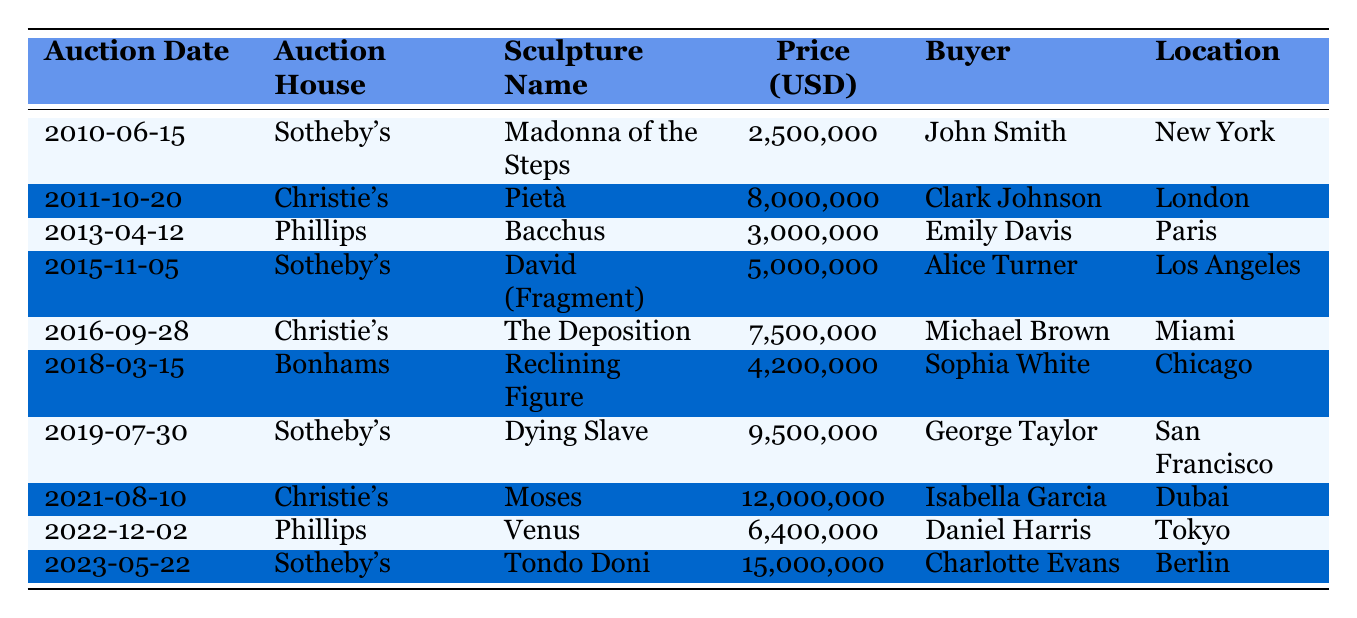What is the highest auction price for a Michelangelo sculpture? The highest price in the table is found in the last entry for "Tondo Doni" at $15,000,000.
Answer: $15,000,000 Who bought the "Pietà"? The buyer for the "Pietà," auctioned on 2011-10-20 at Christie's, is Clark Johnson.
Answer: Clark Johnson How many times was Sotheby's the auction house for Michelangelo's sculptures in this period? By counting the entries in the table, Sotheby's appears 4 times: in 2010, 2015, 2019, and 2023.
Answer: 4 times Which sculpture had the lowest price and who was the buyer? The lowest priced sculpture is "Madonna of the Steps" at $2,500,000, purchased by John Smith.
Answer: "Madonna of the Steps," John Smith What was the average auction price of all the Michelangelo sculptures listed? The total sum of all prices is $66,400,000, and there are 10 sculptures, so the average price is $66,400,000 / 10 = $6,640,000.
Answer: $6,640,000 Did any sculpture sell for more than $10 million? Yes, there are two sculptures that sold for more than $10 million: "Moses" and "Tondo Doni."
Answer: Yes What sculpture was auctioned first, and at what price? The first auction listed is "Madonna of the Steps" on 2010-06-15, and it was sold for $2,500,000.
Answer: "Madonna of the Steps," $2,500,000 In which city was the "Dying Slave" auctioned? The "Dying Slave" sculpture was auctioned on 2019-07-30 in San Francisco.
Answer: San Francisco Which auction house had the highest average selling price for the sculptures? To determine this, we calculate the average selling prices for each auction house: Sotheby's = ($2,500,000 + $5,000,000 + $9,500,000 + $15,000,000) / 4 = $7,250,000; Christie's = ($8,000,000 + $7,500,000 + $12,000,000) / 3 = $9,166,667; and Phillips = ($3,000,000 + $6,400,000) / 2 = $4,700,000. Christie's has the highest average at $9,166,667.
Answer: Christie's What was the total value of all sculptures sold at Phillips? The total for Phillips is $3,000,000 for "Bacchus" and $6,400,000 for "Venus" giving a total of $3,000,000 + $6,400,000 = $9,400,000.
Answer: $9,400,000 How many different buyers purchased sculptures at Christie's? Christie's had three unique buyers: Clark Johnson for "Pietà," Michael Brown for "The Deposition," and Isabella Garcia for "Moses."
Answer: 3 buyers 